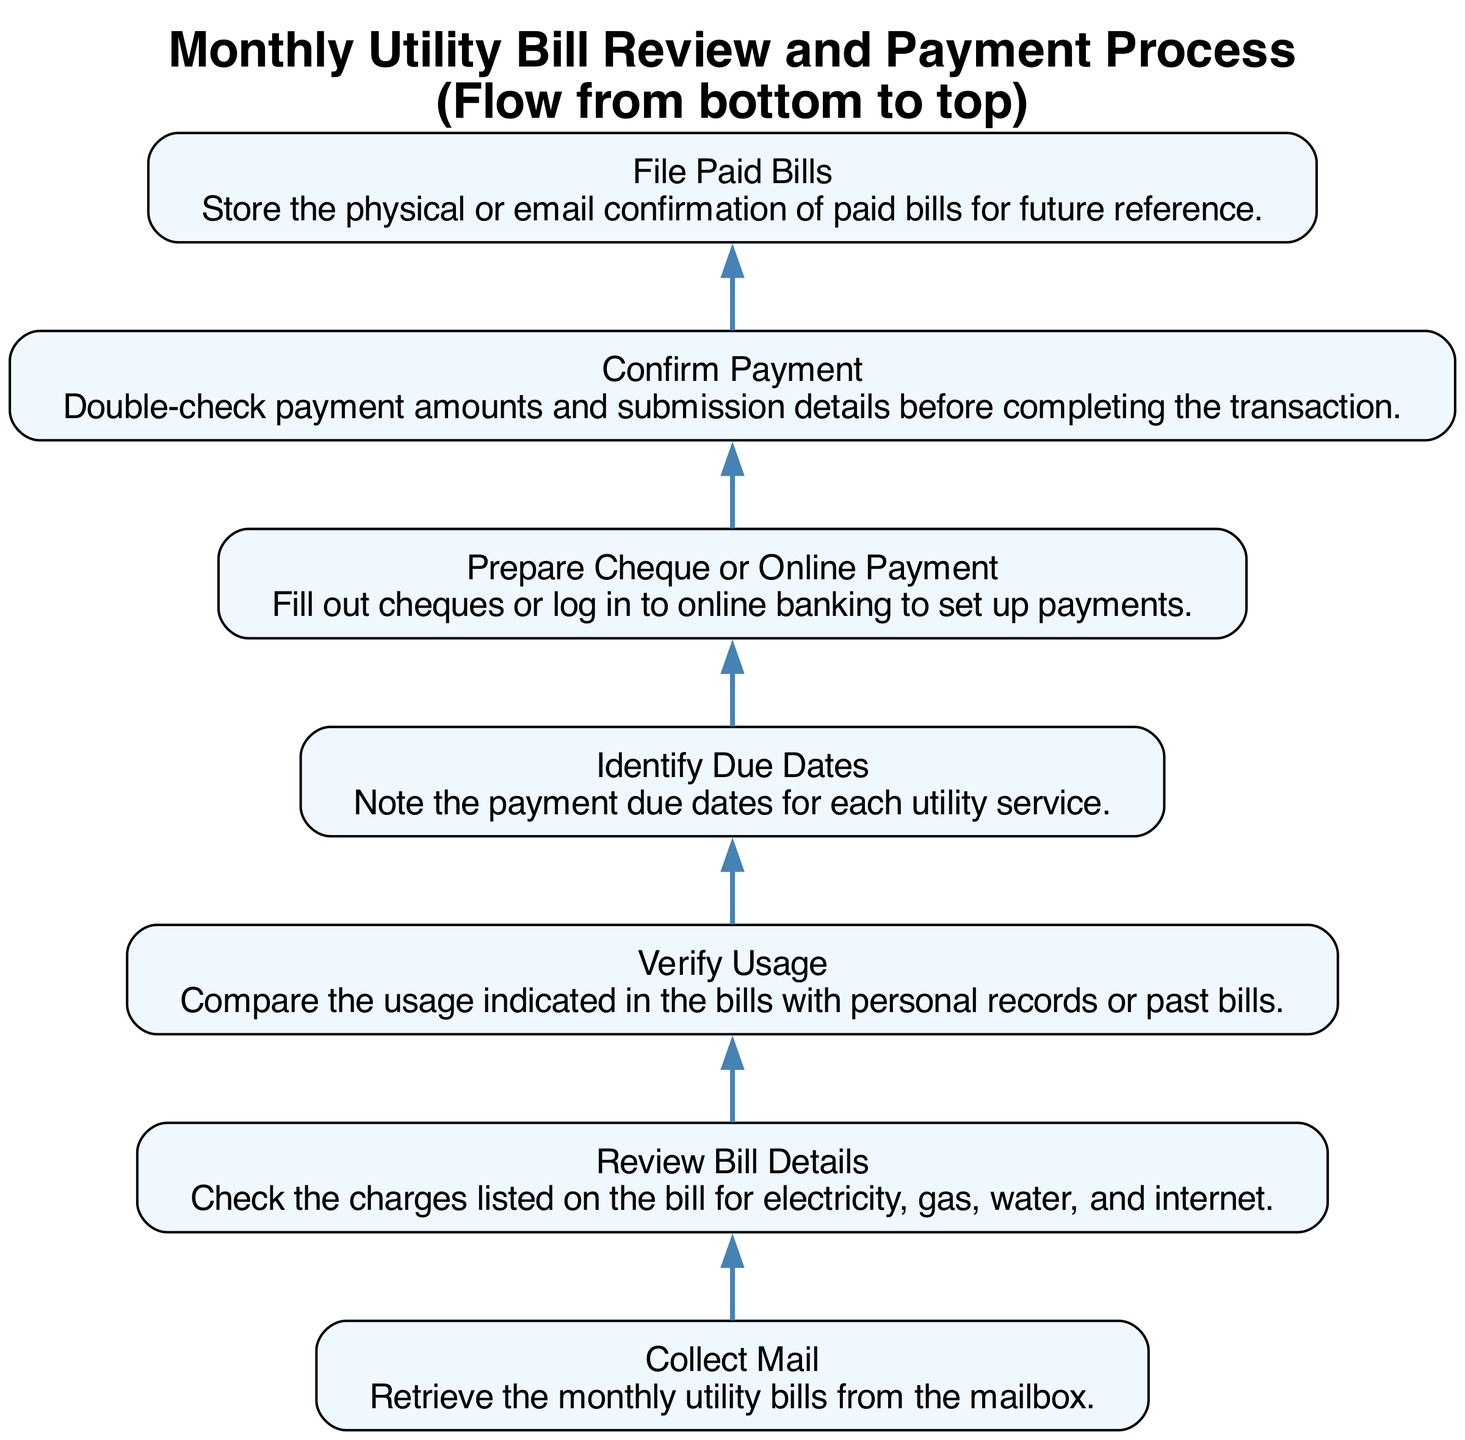What is the first step in the process? The flow chart indicates that the first step is to "Collect Mail," which means to retrieve the monthly utility bills from the mailbox.
Answer: Collect Mail How many steps are there in total in this process? By counting the nodes in the flow chart, we see that there are seven distinct steps from "Collect Mail" to "File Paid Bills."
Answer: 7 What is the final action taken in the process? The last node in the flow chart is "File Paid Bills," indicating that the final action is to store the confirmation of paid bills for future reference.
Answer: File Paid Bills What action directly follows "Verify Usage"? The next step that occurs after "Verify Usage" in the flow chart is "Identify Due Dates." Therefore, after checking on usage, one would then note the payment due dates.
Answer: Identify Due Dates Which step involves confirming payment details? The flow chart shows that the step responsible for confirming payment details is "Confirm Payment," where double-checking of payment amounts occurs.
Answer: Confirm Payment What process is initiated after collecting the mail? After "Collect Mail," the next process initiated is "Review Bill Details," which involves checking the charges listed on the bills for various utilities.
Answer: Review Bill Details Which two steps are required before filing paid bills? Before "File Paid Bills," the steps that must be completed are "Confirm Payment" and "Prepare Cheque or Online Payment," meaning payments need to be prepared and confirmed prior to filing.
Answer: Confirm Payment and Prepare Cheque or Online Payment What is the main purpose of the "Verify Usage" step? The primary purpose of the "Verify Usage" step is to ensure accuracy by comparing the indicated usage with personal records or past bills. This ensures that the bills are correct.
Answer: Compare usage with records What is required to proceed from "Prepare Cheque or Online Payment" to "Confirm Payment"? To move from "Prepare Cheque or Online Payment" to "Confirm Payment," it is necessary to have either filled out a cheque or set up an online payment transaction, which sets the stage for confirming payment details.
Answer: Filled out a cheque or set up an online payment 